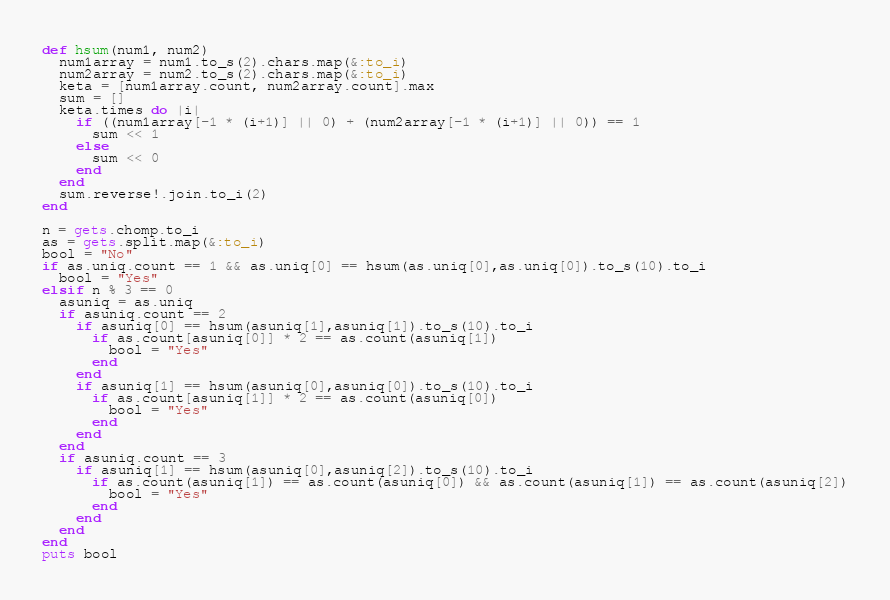Convert code to text. <code><loc_0><loc_0><loc_500><loc_500><_Ruby_>def hsum(num1, num2)
  num1array = num1.to_s(2).chars.map(&:to_i)
  num2array = num2.to_s(2).chars.map(&:to_i)
  keta = [num1array.count, num2array.count].max
  sum = []
  keta.times do |i|
    if ((num1array[-1 * (i+1)] || 0) + (num2array[-1 * (i+1)] || 0)) == 1
      sum << 1
    else
      sum << 0
    end
  end
  sum.reverse!.join.to_i(2)
end

n = gets.chomp.to_i
as = gets.split.map(&:to_i)
bool = "No"
if as.uniq.count == 1 && as.uniq[0] == hsum(as.uniq[0],as.uniq[0]).to_s(10).to_i
  bool = "Yes"
elsif n % 3 == 0
  asuniq = as.uniq
  if asuniq.count == 2
    if asuniq[0] == hsum(asuniq[1],asuniq[1]).to_s(10).to_i
      if as.count[asuniq[0]] * 2 == as.count(asuniq[1])
        bool = "Yes"
      end
    end
    if asuniq[1] == hsum(asuniq[0],asuniq[0]).to_s(10).to_i
      if as.count[asuniq[1]] * 2 == as.count(asuniq[0])
        bool = "Yes"
      end
    end
  end
  if asuniq.count == 3
    if asuniq[1] == hsum(asuniq[0],asuniq[2]).to_s(10).to_i
      if as.count(asuniq[1]) == as.count(asuniq[0]) && as.count(asuniq[1]) == as.count(asuniq[2])
        bool = "Yes"
      end
    end
  end
end
puts bool</code> 